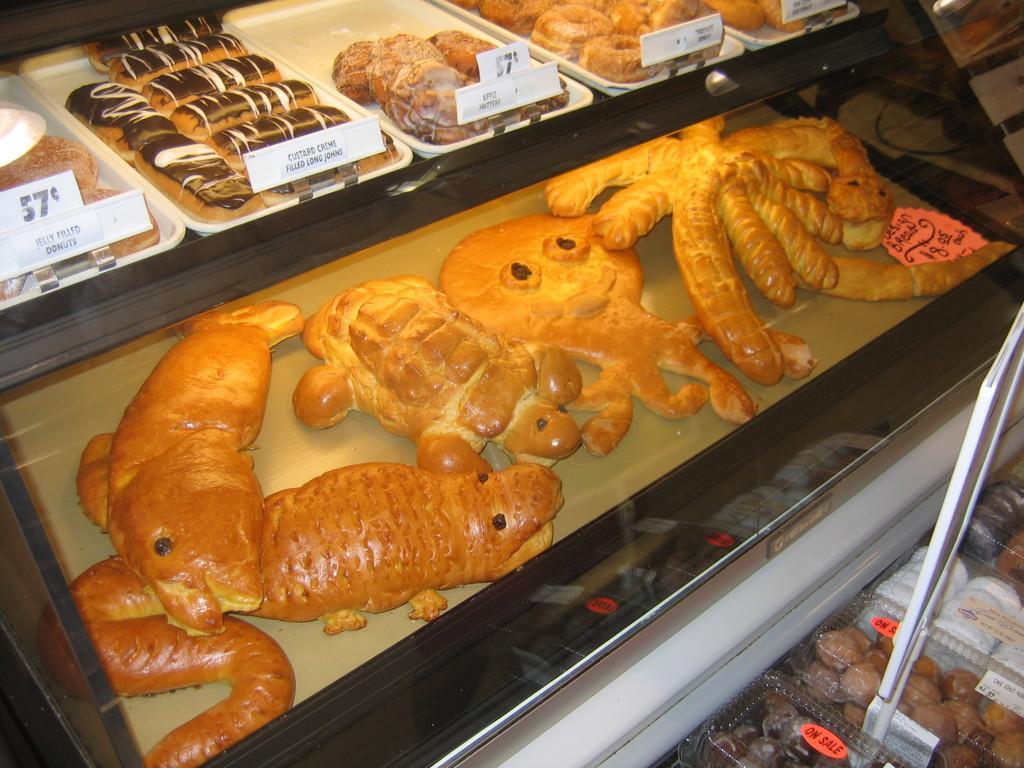Could you give a brief overview of what you see in this image? In this image I can see food items in the trays and there are name plates in front of them. 